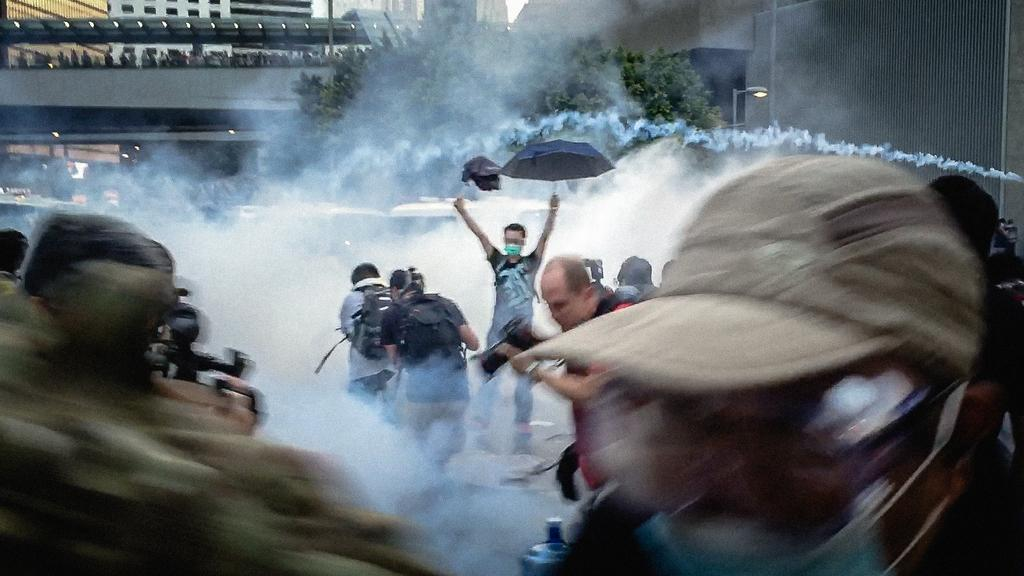What is happening on the road in the image? There are people on the road in the image. Can you describe one of the people in the image? One person is holding an umbrella. What is the weather like in the image? There is fog visible in the image. What can be seen in the background of the image? There are buildings and trees in the background of the image. What type of stamp is the ghost using to communicate in the image? There is no ghost or stamp present in the image. 